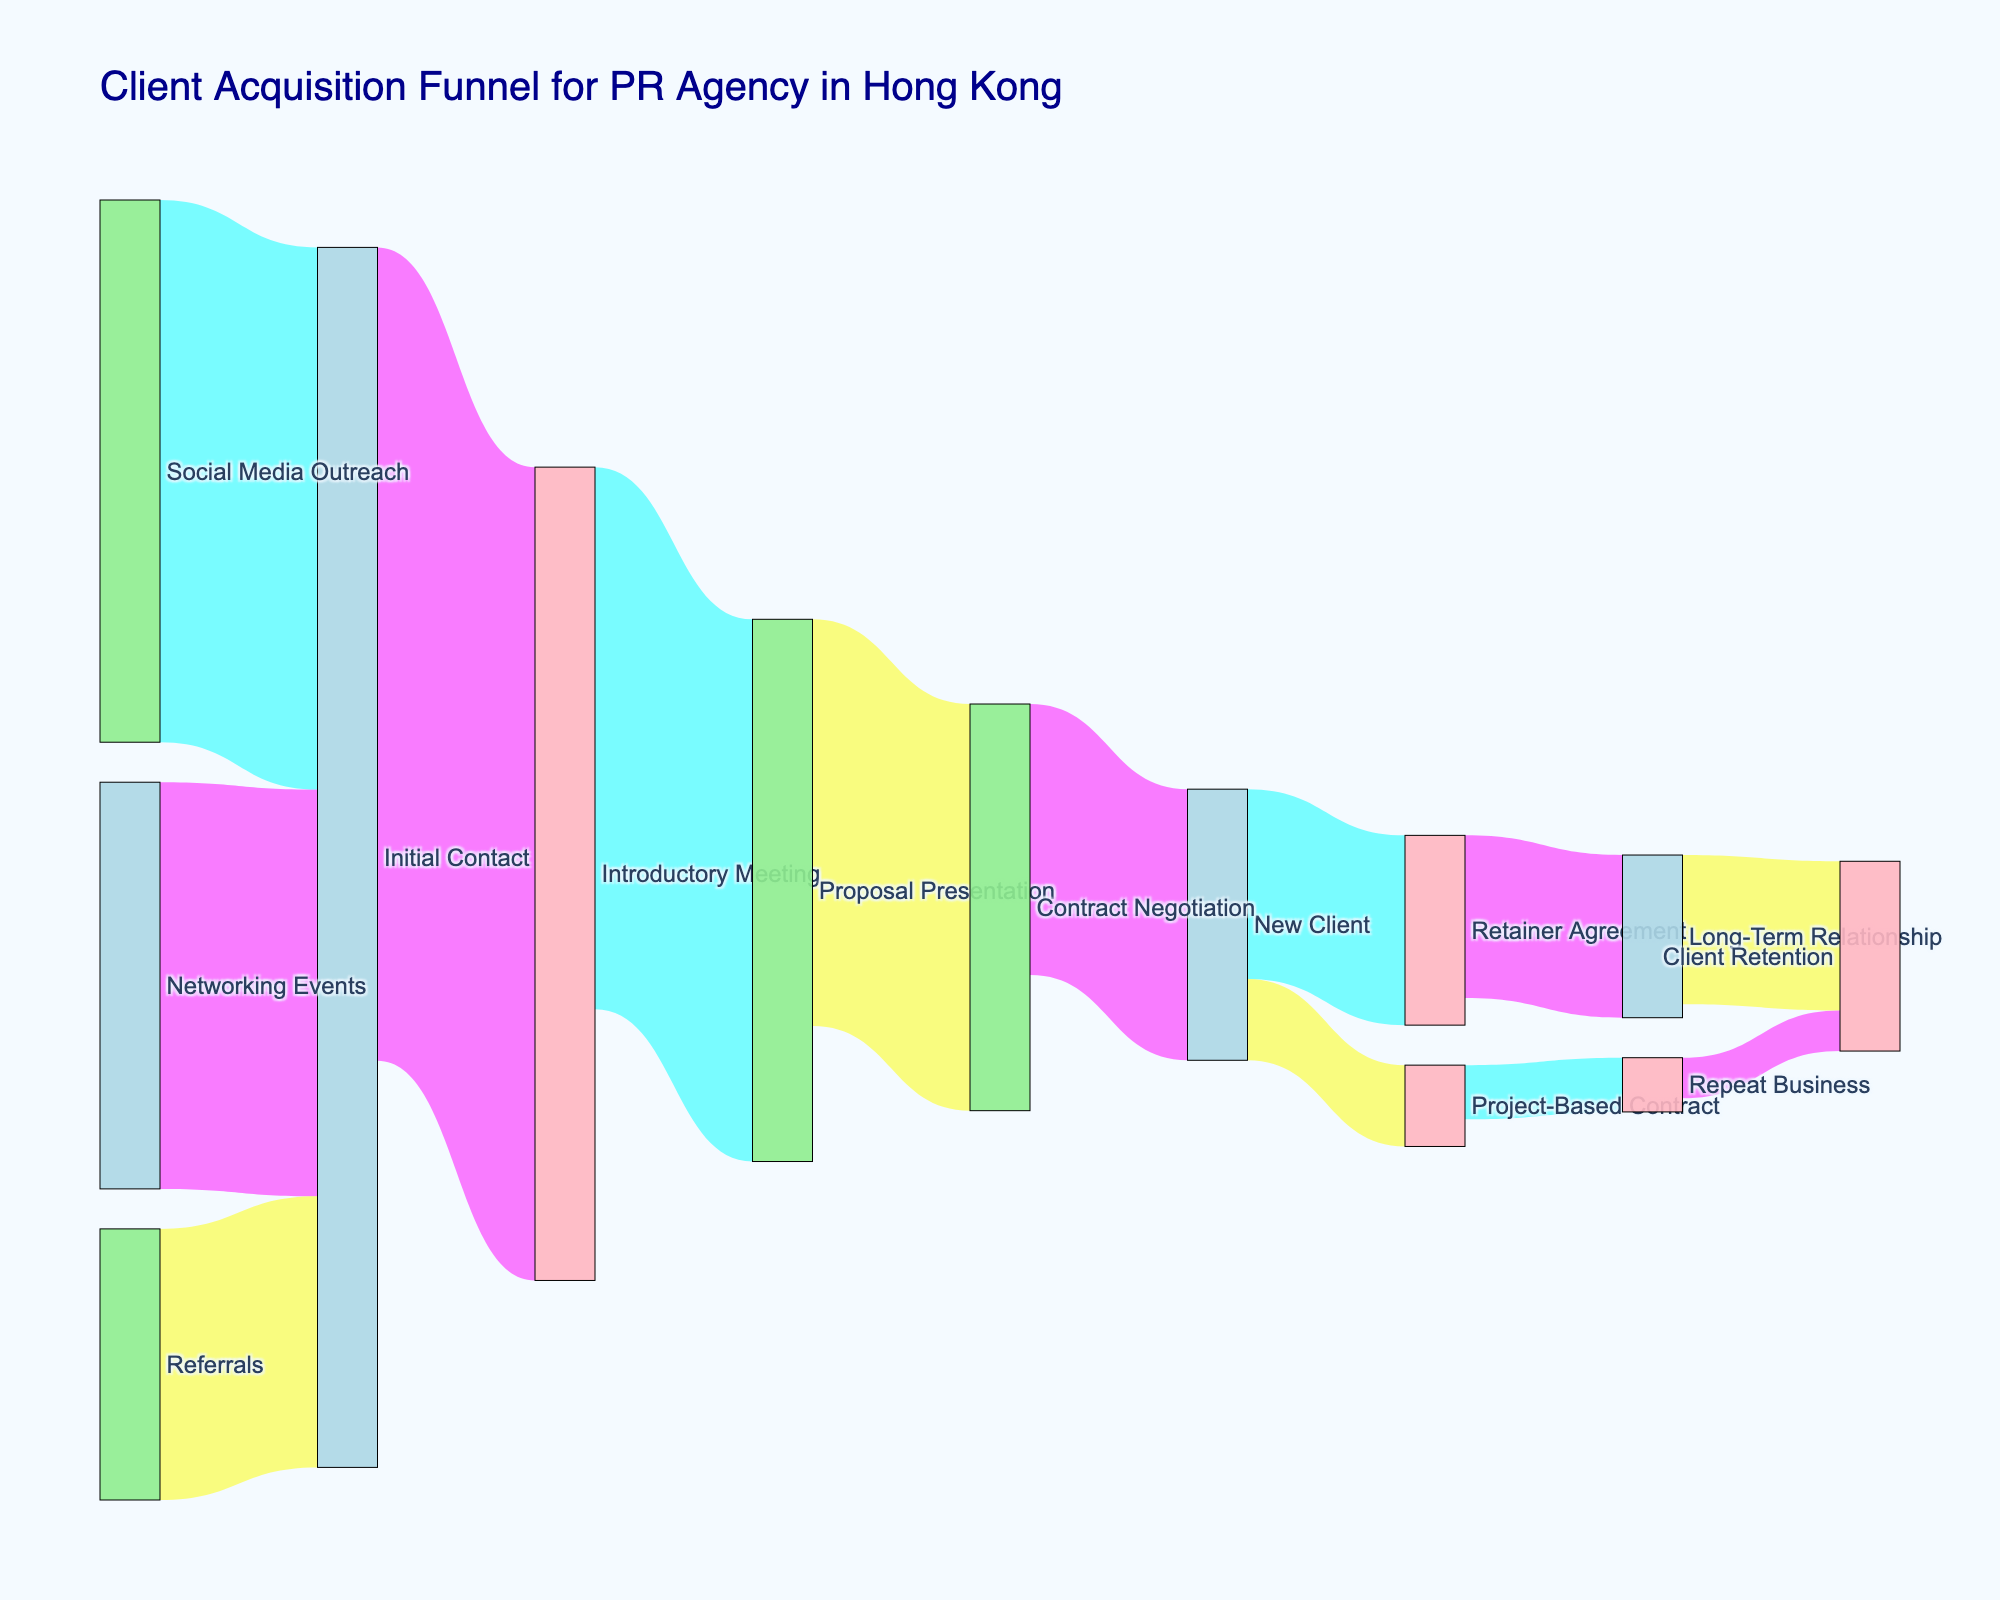How many clients come from Networking Events? Observe the flow from "Networking Events" to "Initial Contact" in the figure. The value associated with this flow is the number of clients, which is 150.
Answer: 150 What is the thickness of the line from "Proposal Presentation" to "Contract Negotiation"? Look at the line that flows from "Proposal Presentation" to "Contract Negotiation" in the diagram. The thickness represents the value of 150 clients.
Answer: 150 How many clients were successfully converted to New Clients from the Contract Negotiation stage? Locate the line that connects "Contract Negotiation" to "New Client" and read the associated value. It shows that 100 clients were converted to New Clients.
Answer: 100 What is the total number of clients who had an Introductory Meeting? Sum the values of incoming and outgoing flows for "Introductory Meeting". It has incoming flow of 300 from "Initial Contact" and outgoing flows totaling 200 to "Proposal Presentation".
Answer: 300 Which source had the highest initial contact value? Compare the initial contact values for "Networking Events" (150), "Social Media Outreach" (200), and "Referrals" (100). "Social Media Outreach" has the highest value.
Answer: Social Media Outreach What is the percentage of New Clients that ended up in a Retainer Agreement? First, find the total number of New Clients (100). Then, find how many moved to Retainer Agreement (70). The percentage is (70/100) * 100.
Answer: 70% Which client acquisition method converted the fewest clients to Initial Contact? Examine the values for "Networking Events" (150), "Social Media Outreach" (200), and "Referrals" (100). "Referrals" have the fewest clients.
Answer: Referrals How many clients were retained in long-term relationships? Trace the flow from "New Client" through "Retainer Agreement" to "Long-Term Relationship," which sums to 60. Then, from "Long-Term Relationship" to "Client Retention" is 55.
Answer: 55 